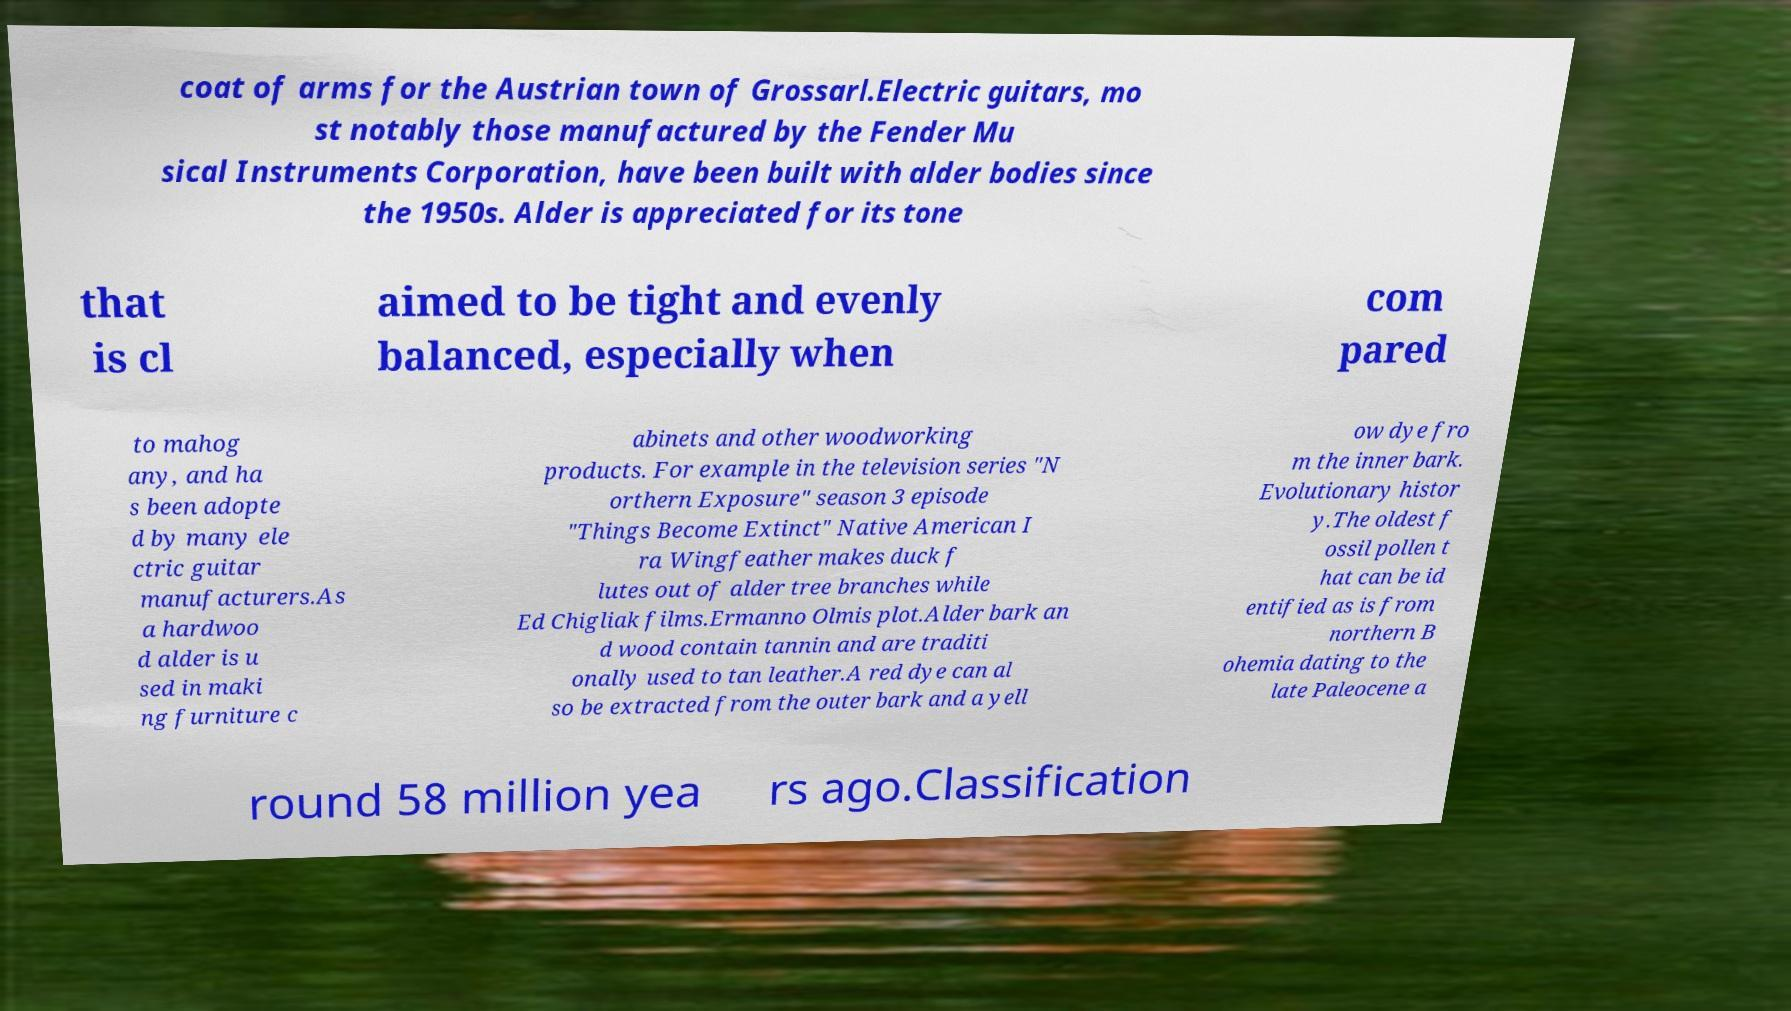What messages or text are displayed in this image? I need them in a readable, typed format. coat of arms for the Austrian town of Grossarl.Electric guitars, mo st notably those manufactured by the Fender Mu sical Instruments Corporation, have been built with alder bodies since the 1950s. Alder is appreciated for its tone that is cl aimed to be tight and evenly balanced, especially when com pared to mahog any, and ha s been adopte d by many ele ctric guitar manufacturers.As a hardwoo d alder is u sed in maki ng furniture c abinets and other woodworking products. For example in the television series "N orthern Exposure" season 3 episode "Things Become Extinct" Native American I ra Wingfeather makes duck f lutes out of alder tree branches while Ed Chigliak films.Ermanno Olmis plot.Alder bark an d wood contain tannin and are traditi onally used to tan leather.A red dye can al so be extracted from the outer bark and a yell ow dye fro m the inner bark. Evolutionary histor y.The oldest f ossil pollen t hat can be id entified as is from northern B ohemia dating to the late Paleocene a round 58 million yea rs ago.Classification 